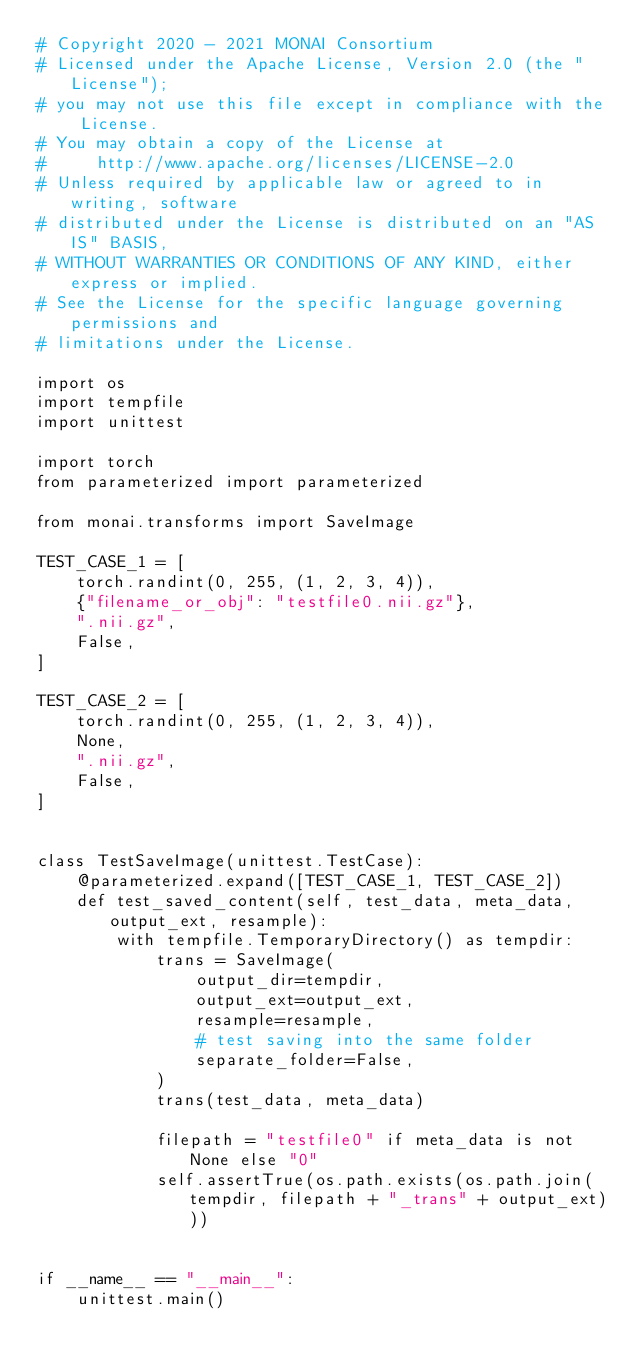<code> <loc_0><loc_0><loc_500><loc_500><_Python_># Copyright 2020 - 2021 MONAI Consortium
# Licensed under the Apache License, Version 2.0 (the "License");
# you may not use this file except in compliance with the License.
# You may obtain a copy of the License at
#     http://www.apache.org/licenses/LICENSE-2.0
# Unless required by applicable law or agreed to in writing, software
# distributed under the License is distributed on an "AS IS" BASIS,
# WITHOUT WARRANTIES OR CONDITIONS OF ANY KIND, either express or implied.
# See the License for the specific language governing permissions and
# limitations under the License.

import os
import tempfile
import unittest

import torch
from parameterized import parameterized

from monai.transforms import SaveImage

TEST_CASE_1 = [
    torch.randint(0, 255, (1, 2, 3, 4)),
    {"filename_or_obj": "testfile0.nii.gz"},
    ".nii.gz",
    False,
]

TEST_CASE_2 = [
    torch.randint(0, 255, (1, 2, 3, 4)),
    None,
    ".nii.gz",
    False,
]


class TestSaveImage(unittest.TestCase):
    @parameterized.expand([TEST_CASE_1, TEST_CASE_2])
    def test_saved_content(self, test_data, meta_data, output_ext, resample):
        with tempfile.TemporaryDirectory() as tempdir:
            trans = SaveImage(
                output_dir=tempdir,
                output_ext=output_ext,
                resample=resample,
                # test saving into the same folder
                separate_folder=False,
            )
            trans(test_data, meta_data)

            filepath = "testfile0" if meta_data is not None else "0"
            self.assertTrue(os.path.exists(os.path.join(tempdir, filepath + "_trans" + output_ext)))


if __name__ == "__main__":
    unittest.main()
</code> 